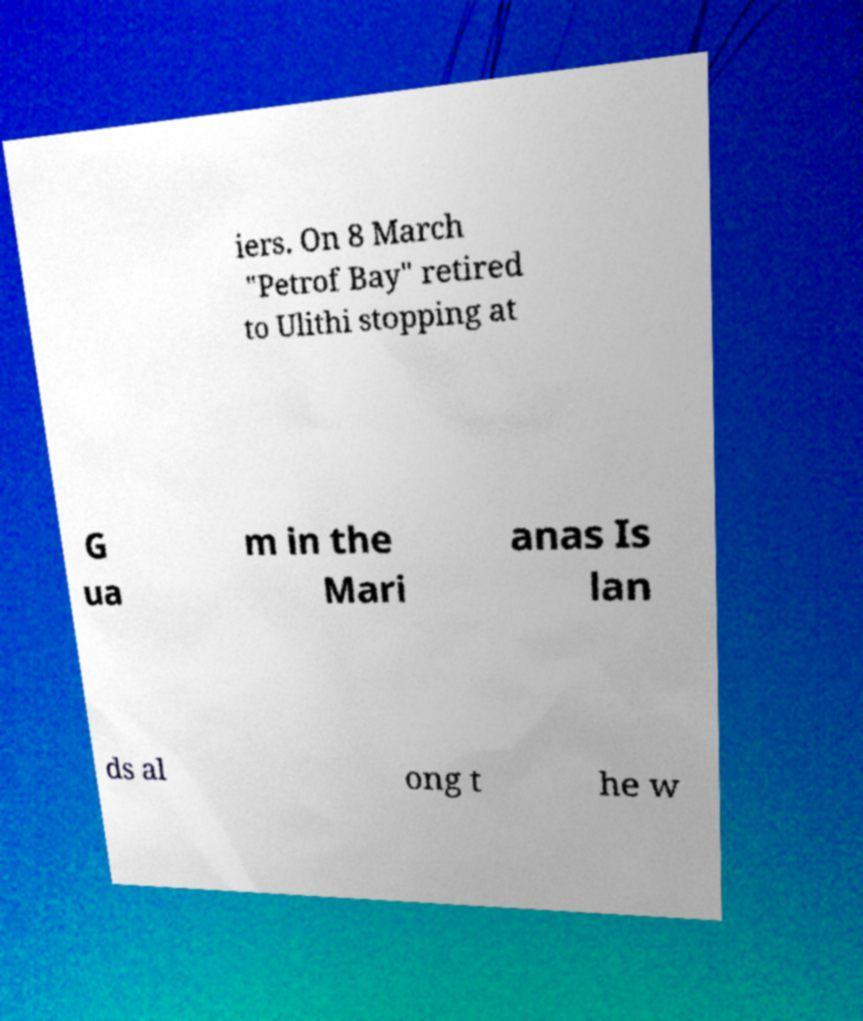Could you extract and type out the text from this image? iers. On 8 March "Petrof Bay" retired to Ulithi stopping at G ua m in the Mari anas Is lan ds al ong t he w 